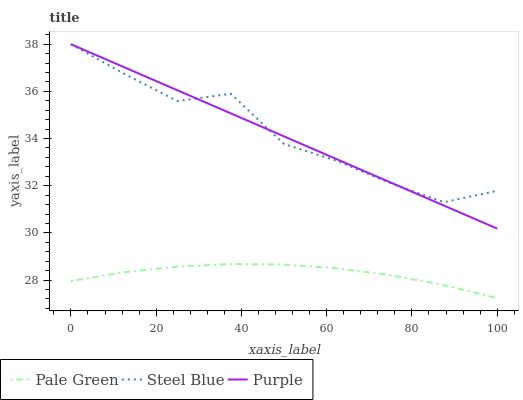Does Steel Blue have the minimum area under the curve?
Answer yes or no. No. Does Pale Green have the maximum area under the curve?
Answer yes or no. No. Is Pale Green the smoothest?
Answer yes or no. No. Is Pale Green the roughest?
Answer yes or no. No. Does Steel Blue have the lowest value?
Answer yes or no. No. Does Pale Green have the highest value?
Answer yes or no. No. Is Pale Green less than Purple?
Answer yes or no. Yes. Is Steel Blue greater than Pale Green?
Answer yes or no. Yes. Does Pale Green intersect Purple?
Answer yes or no. No. 